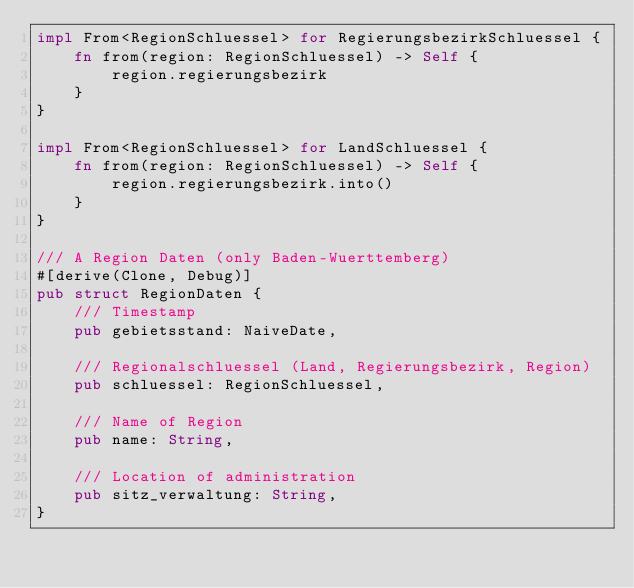<code> <loc_0><loc_0><loc_500><loc_500><_Rust_>impl From<RegionSchluessel> for RegierungsbezirkSchluessel {
    fn from(region: RegionSchluessel) -> Self {
        region.regierungsbezirk
    }
}

impl From<RegionSchluessel> for LandSchluessel {
    fn from(region: RegionSchluessel) -> Self {
        region.regierungsbezirk.into()
    }
}

/// A Region Daten (only Baden-Wuerttemberg)
#[derive(Clone, Debug)]
pub struct RegionDaten {
    /// Timestamp
    pub gebietsstand: NaiveDate,

    /// Regionalschluessel (Land, Regierungsbezirk, Region)
    pub schluessel: RegionSchluessel,

    /// Name of Region
    pub name: String,

    /// Location of administration
    pub sitz_verwaltung: String,
}
</code> 